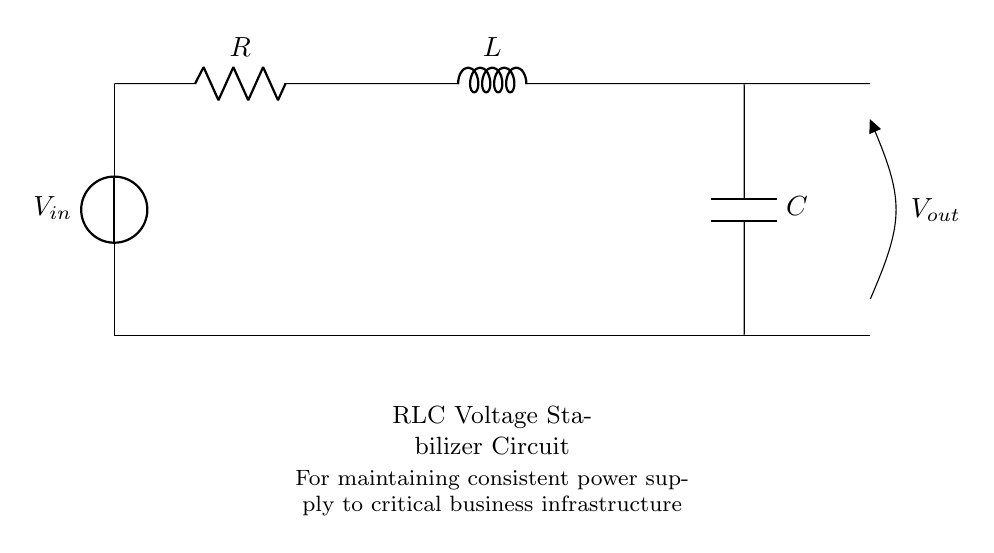What is the input voltage source in this circuit? The input voltage source is labeled as V_in, which indicates where the power supply enters the circuit.
Answer: V_in What component is responsible for storing energy in this circuit? The component that stores energy is the capacitor, denoted by C, which charges and discharges to stabilize voltage.
Answer: C How are the resistor, inductor, and capacitor connected in this circuit? They are connected in series, meaning the current flows through each component one after the other in a single path.
Answer: Series What is the purpose of this RLC circuit? The purpose is to maintain a consistent power supply by stabilizing voltage levels, particularly beneficial for critical business infrastructure.
Answer: Voltage stabilizer What is the output voltage taken from in this circuit? The output voltage, labeled as V_out, is taken across the capacitor, which is where the stabilized voltage is measured and utilized.
Answer: V_out How does the inductor in the circuit contribute to voltage stabilization? The inductor resists changes to current flow, smoothing out fluctuations and helping to provide a steady voltage in conjunction with the resistor and capacitor.
Answer: Smoothing 